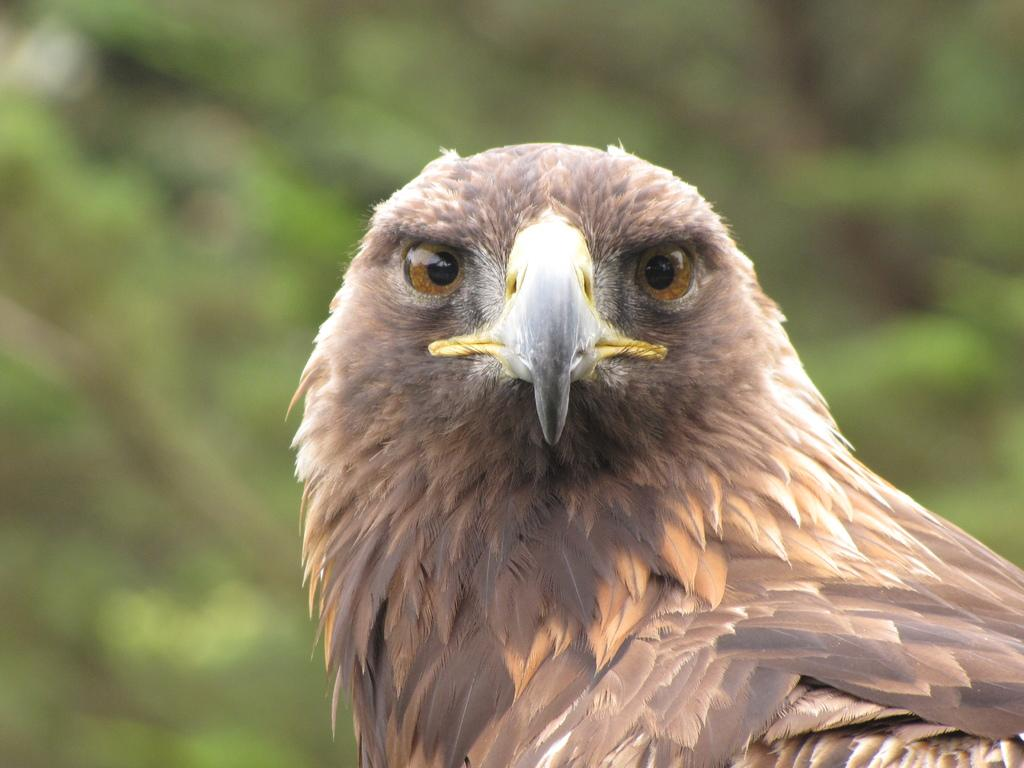What animal is the main subject of the image? There is an eagle in the image. Can you describe the background of the image? The background of the image is blurred. What type of belief does the queen hold about the goat in the image? There is no queen or goat present in the image, so it is not possible to answer that question. 